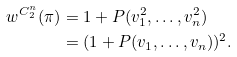<formula> <loc_0><loc_0><loc_500><loc_500>w ^ { C _ { 2 } ^ { n } } ( \pi ) & = 1 + P ( v _ { 1 } ^ { 2 } , \dots , v _ { n } ^ { 2 } ) \\ & = ( 1 + P ( v _ { 1 } , \dots , v _ { n } ) ) ^ { 2 } .</formula> 